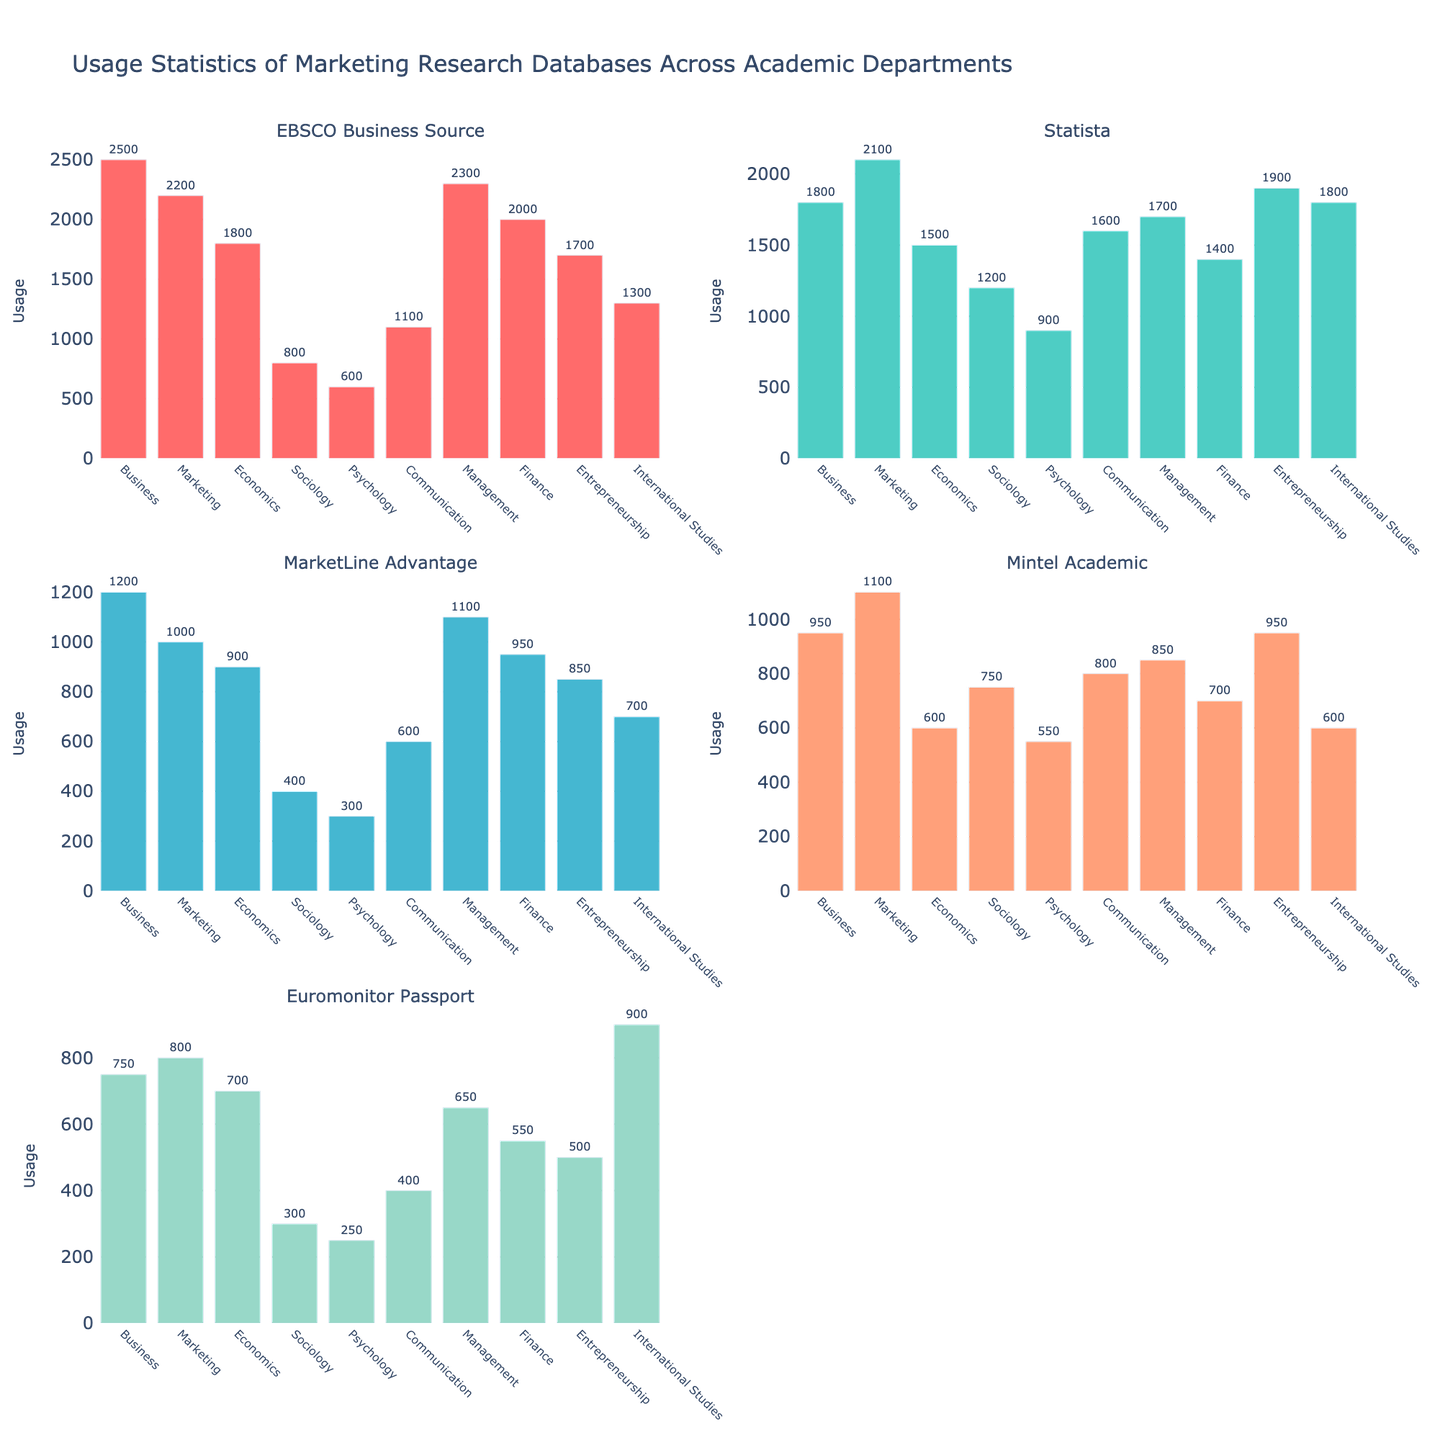What's the title of the overall figure? The title of the figure is located at the top. It provides a summary of what the figure represents.
Answer: Usage Statistics of Marketing Research Databases Across Academic Departments Which department has the highest usage of MarketLine Advantage? Look at the subplot for MarketLine Advantage. Identify the bar with the maximum height and refer to its corresponding department label.
Answer: Business What is the total usage of Euromonitor Passport across all departments? Sum up the values of Euromonitor Passport for each department: 750 + 800 + 700 + 300 + 250 + 400 + 650 + 550 + 500 + 900.
Answer: 5800 Which database is most used by the Marketing department? Find the subplot for the Marketing department and identify the bar with the highest value.
Answer: Statista How does the usage of Statista by the Sociology department compare to the usage by the Business department? Look at the subplot for Statista. Compare the heights of the bars for Sociology (1200) and Business (1800). 1200 is less than 1800.
Answer: Less than What's the average usage of EBSCO Business Source across all departments? Calculate the sum of EBSCO Business Source usage values for all departments and divide by the number of departments: (2500 + 2200 + 1800 + 800 + 600 + 1100 + 2300 + 2000 + 1700 + 1300) / 10.
Answer: 1630 Which department has the lowest usage of Mintel Academic? Locate the subplot for Mintel Academic and identify the shortest bar and its corresponding department label.
Answer: Psychology What are the colors used for each database subplot? Identify the color of the bars in each subplot by looking at their distinct colors.
Answer: EBSCO Business Source: Red, Statista: Teal, MarketLine Advantage: Blue, Mintel Academic: Light orange, Euromonitor Passport: Light green 